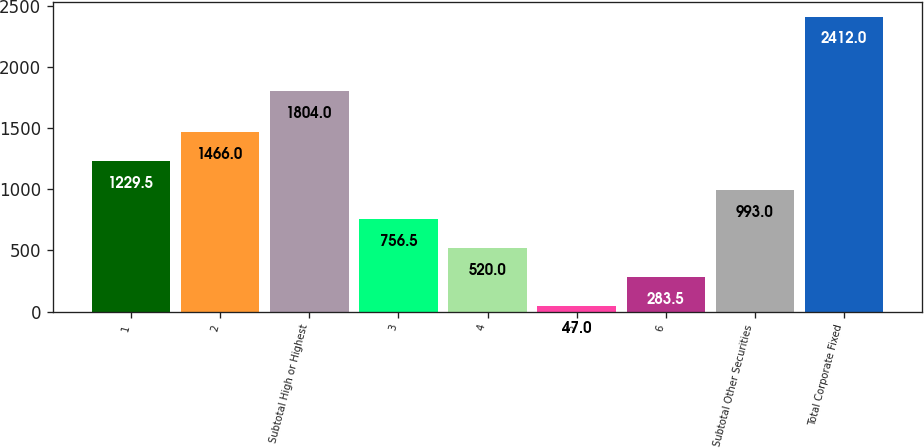Convert chart. <chart><loc_0><loc_0><loc_500><loc_500><bar_chart><fcel>1<fcel>2<fcel>Subtotal High or Highest<fcel>3<fcel>4<fcel>5<fcel>6<fcel>Subtotal Other Securities<fcel>Total Corporate Fixed<nl><fcel>1229.5<fcel>1466<fcel>1804<fcel>756.5<fcel>520<fcel>47<fcel>283.5<fcel>993<fcel>2412<nl></chart> 